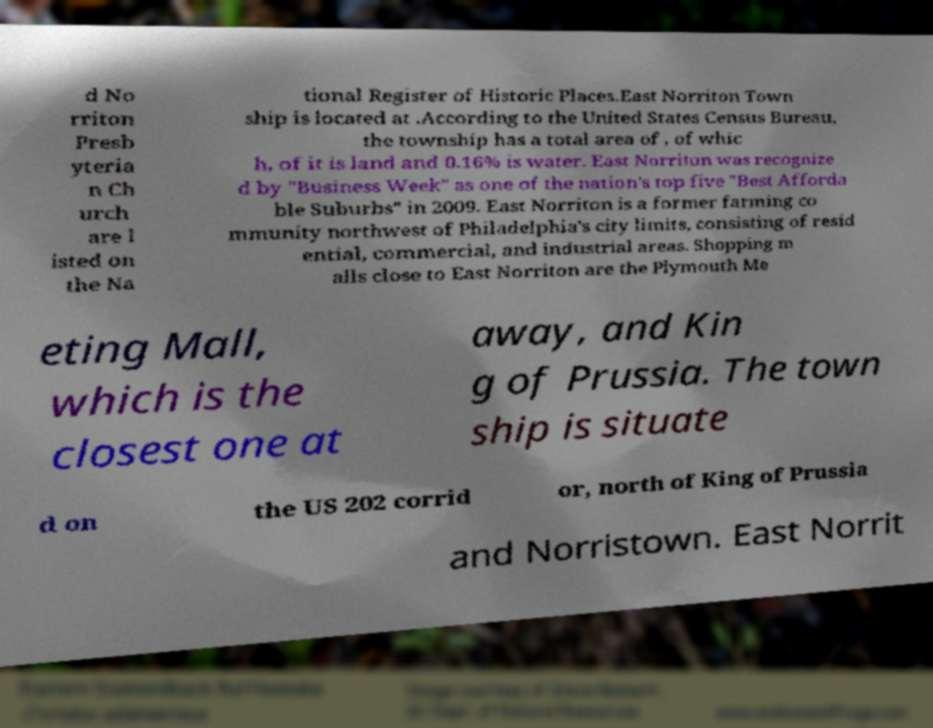Please identify and transcribe the text found in this image. d No rriton Presb yteria n Ch urch are l isted on the Na tional Register of Historic Places.East Norriton Town ship is located at .According to the United States Census Bureau, the township has a total area of , of whic h, of it is land and 0.16% is water. East Norriton was recognize d by "Business Week" as one of the nation's top five "Best Afforda ble Suburbs" in 2009. East Norriton is a former farming co mmunity northwest of Philadelphia's city limits, consisting of resid ential, commercial, and industrial areas. Shopping m alls close to East Norriton are the Plymouth Me eting Mall, which is the closest one at away, and Kin g of Prussia. The town ship is situate d on the US 202 corrid or, north of King of Prussia and Norristown. East Norrit 